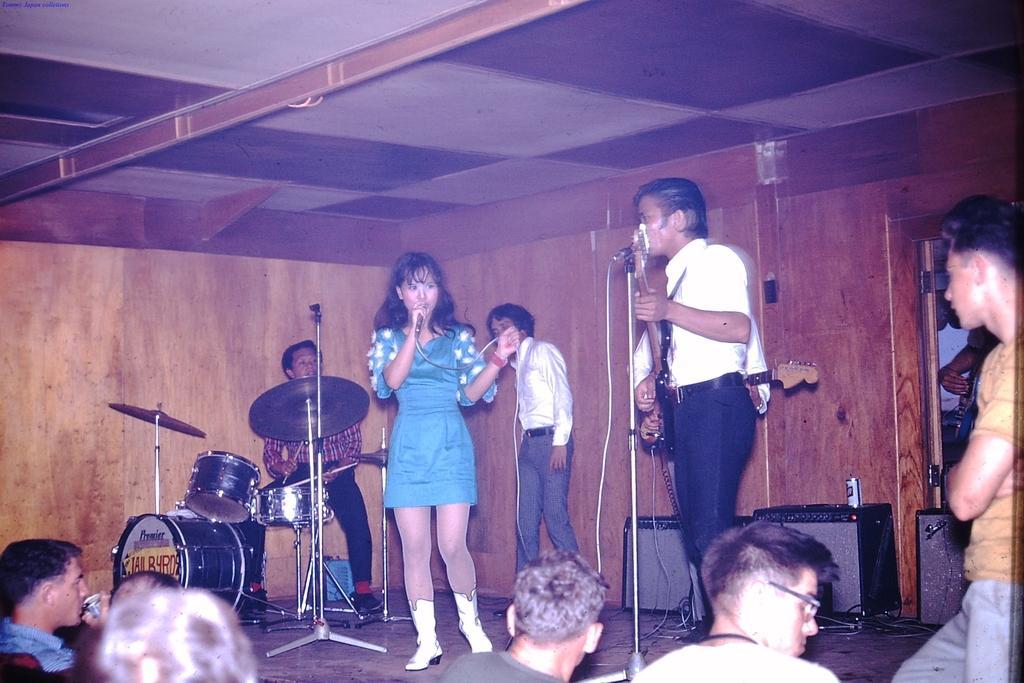Please provide a concise description of this image. This is a picture of a live performance. In the center of the picture on the stage there are a band performing. In the center there is a woman singing holding a microphone. On the right there is a man and standing and playing guitar. On the left there is a man sitting and playing drums. In the background there is a man standing. On the top there is ceiling. In the foreground there is crowd. On the right there is a door. 